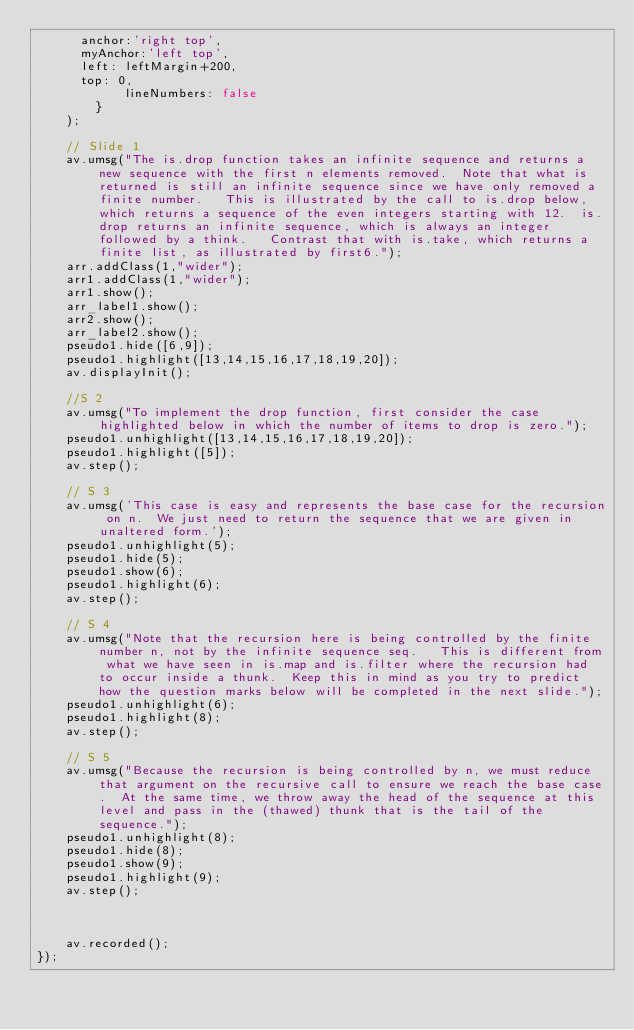Convert code to text. <code><loc_0><loc_0><loc_500><loc_500><_JavaScript_> 	    anchor:'right top',
 	    myAnchor:'left top',
	    left: leftMargin+200,
	    top: 0,
            lineNumbers: false
        }
    );
    
    // Slide 1
    av.umsg("The is.drop function takes an infinite sequence and returns a new sequence with the first n elements removed.  Note that what is returned is still an infinite sequence since we have only removed a finite number.   This is illustrated by the call to is.drop below, which returns a sequence of the even integers starting with 12.  is.drop returns an infinite sequence, which is always an integer followed by a think.   Contrast that with is.take, which returns a finite list, as illustrated by first6.");
    arr.addClass(1,"wider");
    arr1.addClass(1,"wider");
    arr1.show();
    arr_label1.show();
    arr2.show();
    arr_label2.show();
    pseudo1.hide([6,9]);
    pseudo1.highlight([13,14,15,16,17,18,19,20]);
    av.displayInit();

    //S 2
    av.umsg("To implement the drop function, first consider the case highlighted below in which the number of items to drop is zero.");
    pseudo1.unhighlight([13,14,15,16,17,18,19,20]);
    pseudo1.highlight([5]);
    av.step();

    // S 3
    av.umsg('This case is easy and represents the base case for the recursion on n.  We just need to return the sequence that we are given in unaltered form.');
    pseudo1.unhighlight(5);
    pseudo1.hide(5);
    pseudo1.show(6);
    pseudo1.highlight(6);
    av.step();

    // S 4
    av.umsg("Note that the recursion here is being controlled by the finite number n, not by the infinite sequence seq.   This is different from what we have seen in is.map and is.filter where the recursion had to occur inside a thunk.  Keep this in mind as you try to predict how the question marks below will be completed in the next slide.");
    pseudo1.unhighlight(6);
    pseudo1.highlight(8);
    av.step();

    // S 5
    av.umsg("Because the recursion is being controlled by n, we must reduce that argument on the recursive call to ensure we reach the base case.  At the same time, we throw away the head of the sequence at this level and pass in the (thawed) thunk that is the tail of the sequence.");
    pseudo1.unhighlight(8);
    pseudo1.hide(8);
    pseudo1.show(9);
    pseudo1.highlight(9);
    av.step();


    
    av.recorded();
});
</code> 